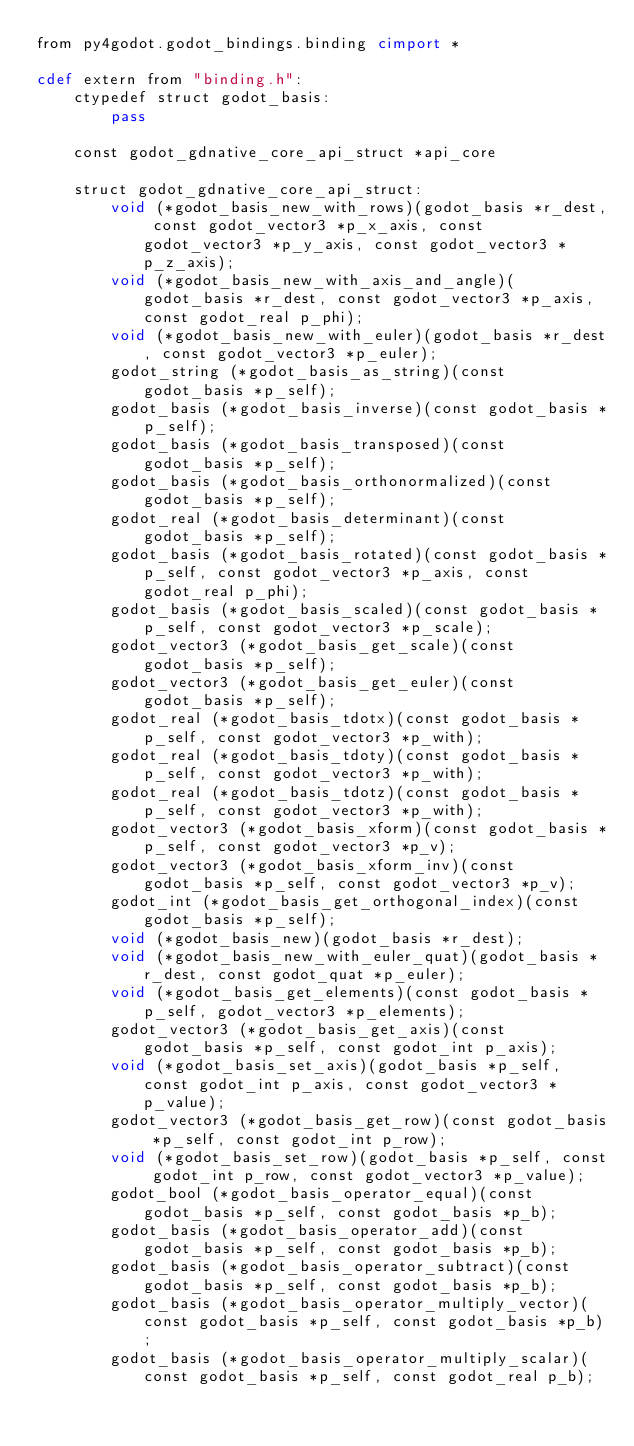<code> <loc_0><loc_0><loc_500><loc_500><_Cython_>from py4godot.godot_bindings.binding cimport *

cdef extern from "binding.h":
    ctypedef struct godot_basis:
        pass

    const godot_gdnative_core_api_struct *api_core

    struct godot_gdnative_core_api_struct:
        void (*godot_basis_new_with_rows)(godot_basis *r_dest, const godot_vector3 *p_x_axis, const godot_vector3 *p_y_axis, const godot_vector3 *p_z_axis);
        void (*godot_basis_new_with_axis_and_angle)(godot_basis *r_dest, const godot_vector3 *p_axis, const godot_real p_phi);
        void (*godot_basis_new_with_euler)(godot_basis *r_dest, const godot_vector3 *p_euler);
        godot_string (*godot_basis_as_string)(const godot_basis *p_self);
        godot_basis (*godot_basis_inverse)(const godot_basis *p_self);
        godot_basis (*godot_basis_transposed)(const godot_basis *p_self);
        godot_basis (*godot_basis_orthonormalized)(const godot_basis *p_self);
        godot_real (*godot_basis_determinant)(const godot_basis *p_self);
        godot_basis (*godot_basis_rotated)(const godot_basis *p_self, const godot_vector3 *p_axis, const godot_real p_phi);
        godot_basis (*godot_basis_scaled)(const godot_basis *p_self, const godot_vector3 *p_scale);
        godot_vector3 (*godot_basis_get_scale)(const godot_basis *p_self);
        godot_vector3 (*godot_basis_get_euler)(const godot_basis *p_self);
        godot_real (*godot_basis_tdotx)(const godot_basis *p_self, const godot_vector3 *p_with);
        godot_real (*godot_basis_tdoty)(const godot_basis *p_self, const godot_vector3 *p_with);
        godot_real (*godot_basis_tdotz)(const godot_basis *p_self, const godot_vector3 *p_with);
        godot_vector3 (*godot_basis_xform)(const godot_basis *p_self, const godot_vector3 *p_v);
        godot_vector3 (*godot_basis_xform_inv)(const godot_basis *p_self, const godot_vector3 *p_v);
        godot_int (*godot_basis_get_orthogonal_index)(const godot_basis *p_self);
        void (*godot_basis_new)(godot_basis *r_dest);
        void (*godot_basis_new_with_euler_quat)(godot_basis *r_dest, const godot_quat *p_euler);
        void (*godot_basis_get_elements)(const godot_basis *p_self, godot_vector3 *p_elements);
        godot_vector3 (*godot_basis_get_axis)(const godot_basis *p_self, const godot_int p_axis);
        void (*godot_basis_set_axis)(godot_basis *p_self, const godot_int p_axis, const godot_vector3 *p_value);
        godot_vector3 (*godot_basis_get_row)(const godot_basis *p_self, const godot_int p_row);
        void (*godot_basis_set_row)(godot_basis *p_self, const godot_int p_row, const godot_vector3 *p_value);
        godot_bool (*godot_basis_operator_equal)(const godot_basis *p_self, const godot_basis *p_b);
        godot_basis (*godot_basis_operator_add)(const godot_basis *p_self, const godot_basis *p_b);
        godot_basis (*godot_basis_operator_subtract)(const godot_basis *p_self, const godot_basis *p_b);
        godot_basis (*godot_basis_operator_multiply_vector)(const godot_basis *p_self, const godot_basis *p_b);
        godot_basis (*godot_basis_operator_multiply_scalar)(const godot_basis *p_self, const godot_real p_b);</code> 